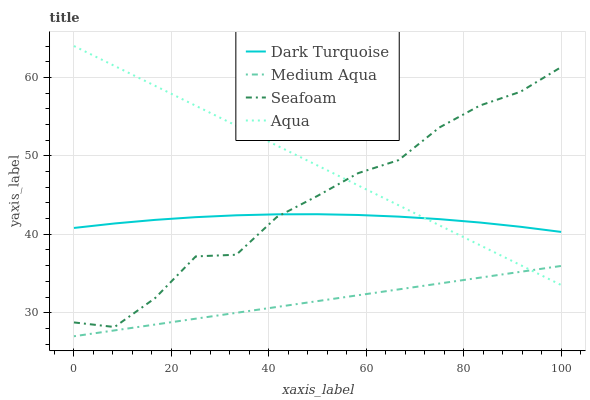Does Medium Aqua have the minimum area under the curve?
Answer yes or no. Yes. Does Aqua have the maximum area under the curve?
Answer yes or no. Yes. Does Dark Turquoise have the minimum area under the curve?
Answer yes or no. No. Does Dark Turquoise have the maximum area under the curve?
Answer yes or no. No. Is Medium Aqua the smoothest?
Answer yes or no. Yes. Is Seafoam the roughest?
Answer yes or no. Yes. Is Dark Turquoise the smoothest?
Answer yes or no. No. Is Dark Turquoise the roughest?
Answer yes or no. No. Does Medium Aqua have the lowest value?
Answer yes or no. Yes. Does Dark Turquoise have the lowest value?
Answer yes or no. No. Does Aqua have the highest value?
Answer yes or no. Yes. Does Dark Turquoise have the highest value?
Answer yes or no. No. Is Medium Aqua less than Seafoam?
Answer yes or no. Yes. Is Seafoam greater than Medium Aqua?
Answer yes or no. Yes. Does Aqua intersect Seafoam?
Answer yes or no. Yes. Is Aqua less than Seafoam?
Answer yes or no. No. Is Aqua greater than Seafoam?
Answer yes or no. No. Does Medium Aqua intersect Seafoam?
Answer yes or no. No. 